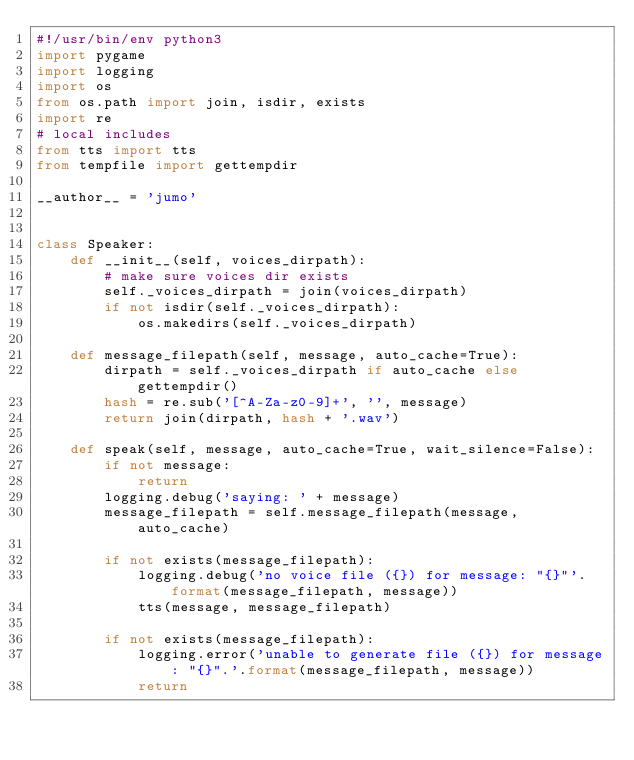<code> <loc_0><loc_0><loc_500><loc_500><_Python_>#!/usr/bin/env python3
import pygame
import logging
import os
from os.path import join, isdir, exists
import re
# local includes
from tts import tts
from tempfile import gettempdir

__author__ = 'jumo'


class Speaker:
    def __init__(self, voices_dirpath):
        # make sure voices dir exists
        self._voices_dirpath = join(voices_dirpath)
        if not isdir(self._voices_dirpath):
            os.makedirs(self._voices_dirpath)

    def message_filepath(self, message, auto_cache=True):
        dirpath = self._voices_dirpath if auto_cache else gettempdir()
        hash = re.sub('[^A-Za-z0-9]+', '', message)
        return join(dirpath, hash + '.wav')

    def speak(self, message, auto_cache=True, wait_silence=False):
        if not message:
            return
        logging.debug('saying: ' + message)
        message_filepath = self.message_filepath(message, auto_cache)

        if not exists(message_filepath):
            logging.debug('no voice file ({}) for message: "{}"'.format(message_filepath, message))
            tts(message, message_filepath)

        if not exists(message_filepath):
            logging.error('unable to generate file ({}) for message: "{}".'.format(message_filepath, message))
            return
</code> 